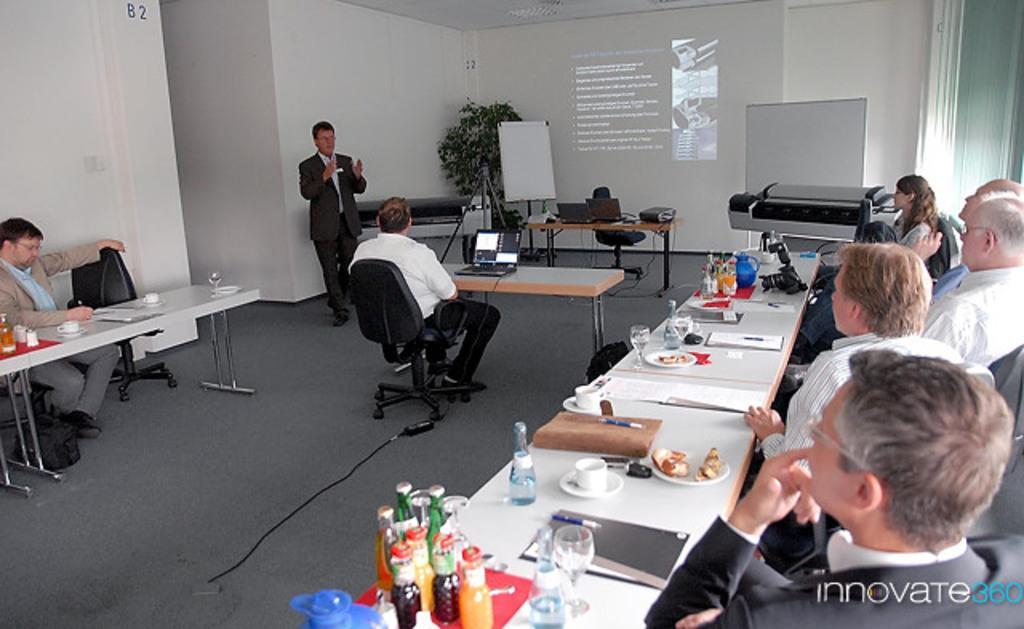Please provide a concise description of this image. In the picture we can see a meeting hall with some people sitting on the chairs near the desks and on the desks we can see some food items in the plate glasses with drinks and some juices and in the opposite side also we can see a man sitting near the desk and in the middle of them we can see a man sitting near the desk and operating something and in the background we can see a man standing and explaining something to them and beside him we can see a table on it we can see a projector machine which is focusing some matter on the screen and besides we can also see a white color board. 